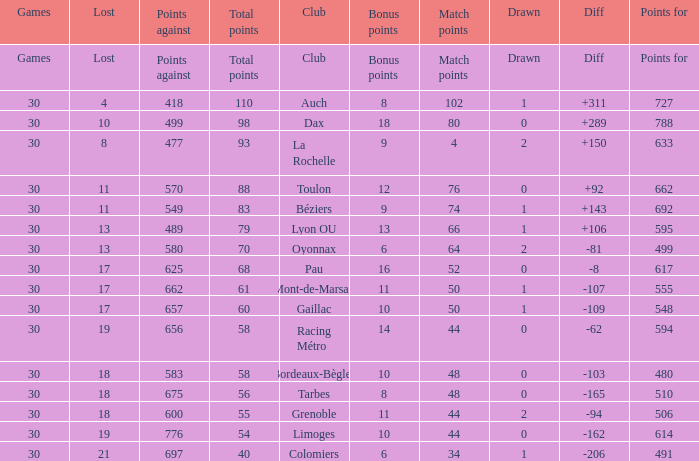What is the number of games for a club that has 34 match points? 30.0. 